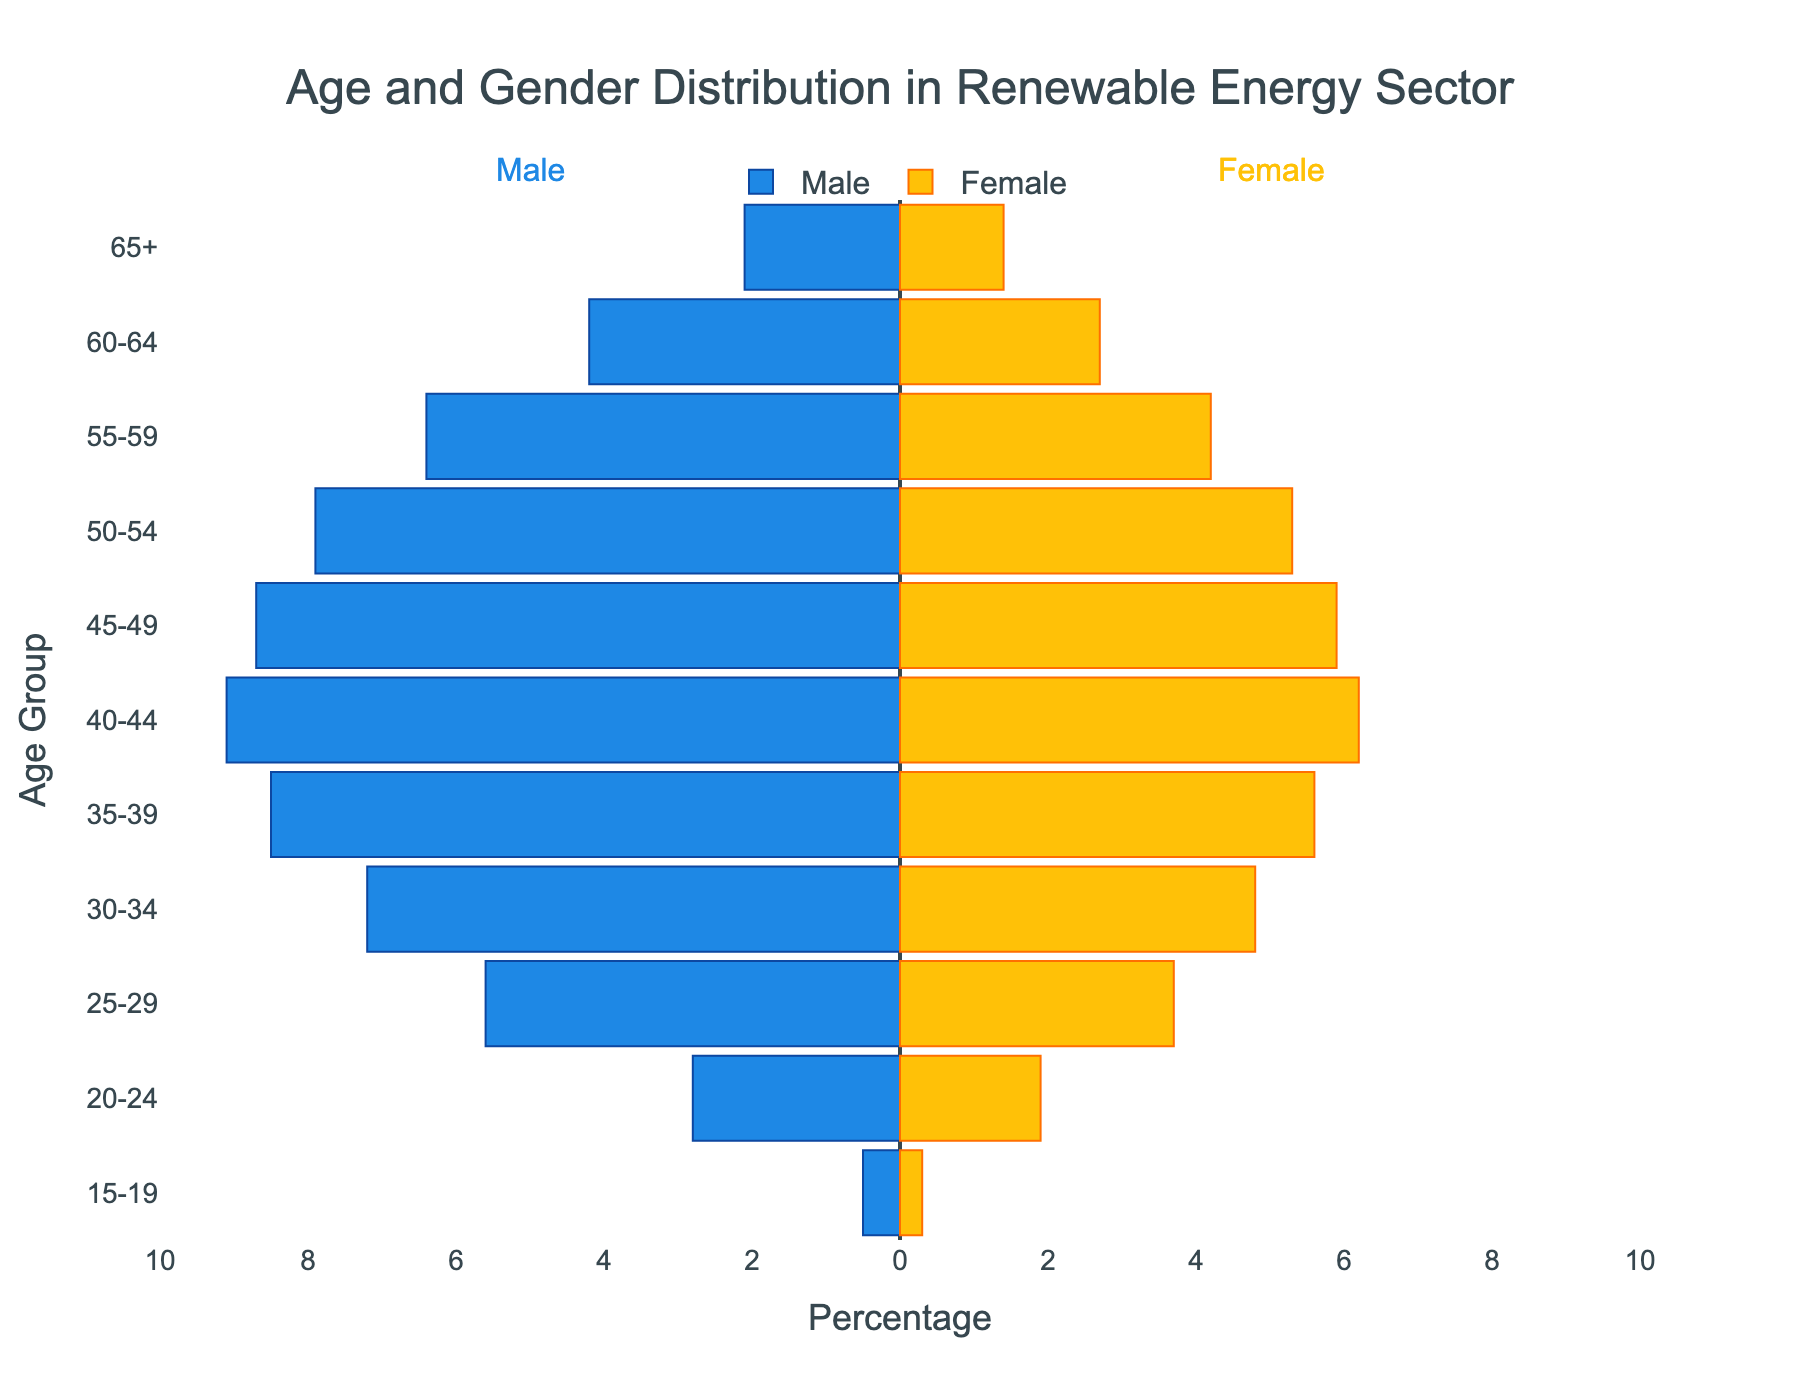what's the title of the figure? The title is located at the top of the figure and reads "Age and Gender Distribution in Renewable Energy Sector".
Answer: Age and Gender Distribution in Renewable Energy Sector what is the age group with the highest percentage of male employees? The age group 40-44 has the longest negative bar on the left side of the plot for males, indicating it has the highest percentage.
Answer: 40-44 how many different age groups are represented in the figure? Each horizontal bar in the plot corresponds to an age group. By counting them, we get the total number of age groups.
Answer: 11 what is the difference in the percentage of male and female employees in the 25-29 age group? Look at the lengths of the bars for males and females in the 25-29 age group: the male percentage is 5.6% and the female percentage is 3.7%. Subtract the smaller from the larger.
Answer: 1.9% which gender has a higher percentage in the 55-59 age group? Compare the length of the bar for males to the one for females in the 55-59 age group. The male bar is longer indicating a higher percentage.
Answer: Male what is the sum of the percentages for male employees in the 20-24 and 60-64 age groups? The percentages for male employees are 2.8% (20-24) and 4.2% (60-64). Adding these together gives 2.8 + 4.2 = 7.0.
Answer: 7.0% what percentage of female employees are in the youngest age group? The first bar on the right (female) in the youngest age group (15-19) shows the percentage as 0.3%.
Answer: 0.3% are there more male or female employees in the 65+ age group? Compare the percentage bars for males and females in the 65+ age group. The male bar is longer which indicates there are more male employees.
Answer: Male Which age group has the smallest difference between male and female employees? Examine the bars for all age groups and find the pair with the closest lengths. The 50-54 age group has a difference of 7.9% - 5.3% = 2.6%, which is one of the smallest among the groups.
Answer: 50-54 Which age group has the highest total percentage of employees when combining males and females? To find the highest total percentage, add the male and female percentages for each age group. The 40-44 age group has 9.1% (males) + 6.2% (females) = 15.3%, which is the highest combined total.
Answer: 40-44 